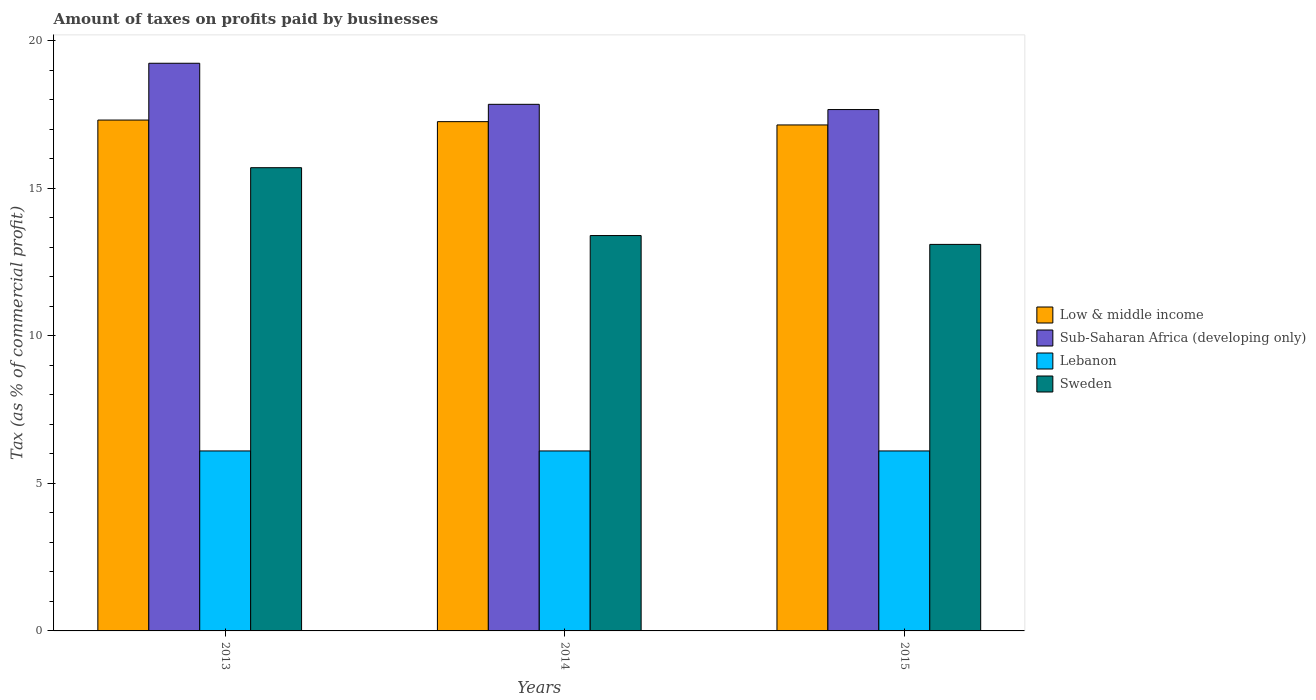How many groups of bars are there?
Provide a succinct answer. 3. Are the number of bars per tick equal to the number of legend labels?
Make the answer very short. Yes. Are the number of bars on each tick of the X-axis equal?
Make the answer very short. Yes. How many bars are there on the 2nd tick from the left?
Give a very brief answer. 4. How many bars are there on the 3rd tick from the right?
Make the answer very short. 4. What is the label of the 3rd group of bars from the left?
Provide a succinct answer. 2015. In how many cases, is the number of bars for a given year not equal to the number of legend labels?
Give a very brief answer. 0. What is the percentage of taxes paid by businesses in Sub-Saharan Africa (developing only) in 2014?
Give a very brief answer. 17.85. Across all years, what is the maximum percentage of taxes paid by businesses in Low & middle income?
Your answer should be very brief. 17.31. Across all years, what is the minimum percentage of taxes paid by businesses in Low & middle income?
Keep it short and to the point. 17.15. In which year was the percentage of taxes paid by businesses in Sub-Saharan Africa (developing only) minimum?
Make the answer very short. 2015. What is the total percentage of taxes paid by businesses in Sub-Saharan Africa (developing only) in the graph?
Keep it short and to the point. 54.76. What is the difference between the percentage of taxes paid by businesses in Sweden in 2014 and that in 2015?
Your answer should be very brief. 0.3. What is the difference between the percentage of taxes paid by businesses in Lebanon in 2014 and the percentage of taxes paid by businesses in Low & middle income in 2013?
Give a very brief answer. -11.21. What is the average percentage of taxes paid by businesses in Sub-Saharan Africa (developing only) per year?
Provide a succinct answer. 18.25. In the year 2014, what is the difference between the percentage of taxes paid by businesses in Low & middle income and percentage of taxes paid by businesses in Sub-Saharan Africa (developing only)?
Offer a very short reply. -0.59. What is the ratio of the percentage of taxes paid by businesses in Sweden in 2014 to that in 2015?
Offer a terse response. 1.02. Is the percentage of taxes paid by businesses in Lebanon in 2014 less than that in 2015?
Keep it short and to the point. No. What is the difference between the highest and the second highest percentage of taxes paid by businesses in Sweden?
Provide a succinct answer. 2.3. What is the difference between the highest and the lowest percentage of taxes paid by businesses in Lebanon?
Provide a succinct answer. 0. In how many years, is the percentage of taxes paid by businesses in Lebanon greater than the average percentage of taxes paid by businesses in Lebanon taken over all years?
Your answer should be compact. 3. Is the sum of the percentage of taxes paid by businesses in Lebanon in 2014 and 2015 greater than the maximum percentage of taxes paid by businesses in Low & middle income across all years?
Offer a very short reply. No. What does the 3rd bar from the left in 2013 represents?
Your answer should be compact. Lebanon. What does the 4th bar from the right in 2013 represents?
Ensure brevity in your answer.  Low & middle income. Is it the case that in every year, the sum of the percentage of taxes paid by businesses in Lebanon and percentage of taxes paid by businesses in Low & middle income is greater than the percentage of taxes paid by businesses in Sub-Saharan Africa (developing only)?
Give a very brief answer. Yes. How many bars are there?
Ensure brevity in your answer.  12. Are all the bars in the graph horizontal?
Your response must be concise. No. Are the values on the major ticks of Y-axis written in scientific E-notation?
Keep it short and to the point. No. Does the graph contain any zero values?
Your answer should be compact. No. What is the title of the graph?
Ensure brevity in your answer.  Amount of taxes on profits paid by businesses. What is the label or title of the Y-axis?
Provide a succinct answer. Tax (as % of commercial profit). What is the Tax (as % of commercial profit) of Low & middle income in 2013?
Your answer should be compact. 17.31. What is the Tax (as % of commercial profit) of Sub-Saharan Africa (developing only) in 2013?
Offer a very short reply. 19.24. What is the Tax (as % of commercial profit) of Sweden in 2013?
Make the answer very short. 15.7. What is the Tax (as % of commercial profit) in Low & middle income in 2014?
Ensure brevity in your answer.  17.26. What is the Tax (as % of commercial profit) in Sub-Saharan Africa (developing only) in 2014?
Your response must be concise. 17.85. What is the Tax (as % of commercial profit) in Lebanon in 2014?
Your response must be concise. 6.1. What is the Tax (as % of commercial profit) in Low & middle income in 2015?
Provide a succinct answer. 17.15. What is the Tax (as % of commercial profit) of Sub-Saharan Africa (developing only) in 2015?
Make the answer very short. 17.67. What is the Tax (as % of commercial profit) in Lebanon in 2015?
Offer a very short reply. 6.1. What is the Tax (as % of commercial profit) of Sweden in 2015?
Give a very brief answer. 13.1. Across all years, what is the maximum Tax (as % of commercial profit) of Low & middle income?
Make the answer very short. 17.31. Across all years, what is the maximum Tax (as % of commercial profit) in Sub-Saharan Africa (developing only)?
Your response must be concise. 19.24. Across all years, what is the maximum Tax (as % of commercial profit) in Lebanon?
Ensure brevity in your answer.  6.1. Across all years, what is the maximum Tax (as % of commercial profit) in Sweden?
Your answer should be compact. 15.7. Across all years, what is the minimum Tax (as % of commercial profit) in Low & middle income?
Keep it short and to the point. 17.15. Across all years, what is the minimum Tax (as % of commercial profit) of Sub-Saharan Africa (developing only)?
Offer a very short reply. 17.67. Across all years, what is the minimum Tax (as % of commercial profit) of Sweden?
Your answer should be very brief. 13.1. What is the total Tax (as % of commercial profit) in Low & middle income in the graph?
Provide a succinct answer. 51.72. What is the total Tax (as % of commercial profit) in Sub-Saharan Africa (developing only) in the graph?
Your answer should be very brief. 54.76. What is the total Tax (as % of commercial profit) in Sweden in the graph?
Keep it short and to the point. 42.2. What is the difference between the Tax (as % of commercial profit) of Low & middle income in 2013 and that in 2014?
Your answer should be compact. 0.05. What is the difference between the Tax (as % of commercial profit) of Sub-Saharan Africa (developing only) in 2013 and that in 2014?
Keep it short and to the point. 1.39. What is the difference between the Tax (as % of commercial profit) of Lebanon in 2013 and that in 2014?
Ensure brevity in your answer.  0. What is the difference between the Tax (as % of commercial profit) in Sweden in 2013 and that in 2014?
Your response must be concise. 2.3. What is the difference between the Tax (as % of commercial profit) in Low & middle income in 2013 and that in 2015?
Offer a terse response. 0.17. What is the difference between the Tax (as % of commercial profit) in Sub-Saharan Africa (developing only) in 2013 and that in 2015?
Ensure brevity in your answer.  1.57. What is the difference between the Tax (as % of commercial profit) of Lebanon in 2013 and that in 2015?
Your answer should be compact. 0. What is the difference between the Tax (as % of commercial profit) in Low & middle income in 2014 and that in 2015?
Give a very brief answer. 0.11. What is the difference between the Tax (as % of commercial profit) in Sub-Saharan Africa (developing only) in 2014 and that in 2015?
Offer a very short reply. 0.18. What is the difference between the Tax (as % of commercial profit) in Lebanon in 2014 and that in 2015?
Give a very brief answer. 0. What is the difference between the Tax (as % of commercial profit) of Low & middle income in 2013 and the Tax (as % of commercial profit) of Sub-Saharan Africa (developing only) in 2014?
Offer a very short reply. -0.53. What is the difference between the Tax (as % of commercial profit) in Low & middle income in 2013 and the Tax (as % of commercial profit) in Lebanon in 2014?
Ensure brevity in your answer.  11.21. What is the difference between the Tax (as % of commercial profit) of Low & middle income in 2013 and the Tax (as % of commercial profit) of Sweden in 2014?
Your response must be concise. 3.91. What is the difference between the Tax (as % of commercial profit) in Sub-Saharan Africa (developing only) in 2013 and the Tax (as % of commercial profit) in Lebanon in 2014?
Make the answer very short. 13.14. What is the difference between the Tax (as % of commercial profit) in Sub-Saharan Africa (developing only) in 2013 and the Tax (as % of commercial profit) in Sweden in 2014?
Give a very brief answer. 5.84. What is the difference between the Tax (as % of commercial profit) of Lebanon in 2013 and the Tax (as % of commercial profit) of Sweden in 2014?
Ensure brevity in your answer.  -7.3. What is the difference between the Tax (as % of commercial profit) in Low & middle income in 2013 and the Tax (as % of commercial profit) in Sub-Saharan Africa (developing only) in 2015?
Provide a succinct answer. -0.36. What is the difference between the Tax (as % of commercial profit) of Low & middle income in 2013 and the Tax (as % of commercial profit) of Lebanon in 2015?
Keep it short and to the point. 11.21. What is the difference between the Tax (as % of commercial profit) in Low & middle income in 2013 and the Tax (as % of commercial profit) in Sweden in 2015?
Give a very brief answer. 4.21. What is the difference between the Tax (as % of commercial profit) in Sub-Saharan Africa (developing only) in 2013 and the Tax (as % of commercial profit) in Lebanon in 2015?
Give a very brief answer. 13.14. What is the difference between the Tax (as % of commercial profit) in Sub-Saharan Africa (developing only) in 2013 and the Tax (as % of commercial profit) in Sweden in 2015?
Provide a short and direct response. 6.14. What is the difference between the Tax (as % of commercial profit) in Low & middle income in 2014 and the Tax (as % of commercial profit) in Sub-Saharan Africa (developing only) in 2015?
Ensure brevity in your answer.  -0.41. What is the difference between the Tax (as % of commercial profit) in Low & middle income in 2014 and the Tax (as % of commercial profit) in Lebanon in 2015?
Your answer should be compact. 11.16. What is the difference between the Tax (as % of commercial profit) in Low & middle income in 2014 and the Tax (as % of commercial profit) in Sweden in 2015?
Keep it short and to the point. 4.16. What is the difference between the Tax (as % of commercial profit) of Sub-Saharan Africa (developing only) in 2014 and the Tax (as % of commercial profit) of Lebanon in 2015?
Offer a terse response. 11.75. What is the difference between the Tax (as % of commercial profit) of Sub-Saharan Africa (developing only) in 2014 and the Tax (as % of commercial profit) of Sweden in 2015?
Your answer should be compact. 4.75. What is the average Tax (as % of commercial profit) in Low & middle income per year?
Offer a very short reply. 17.24. What is the average Tax (as % of commercial profit) of Sub-Saharan Africa (developing only) per year?
Offer a very short reply. 18.25. What is the average Tax (as % of commercial profit) in Sweden per year?
Keep it short and to the point. 14.07. In the year 2013, what is the difference between the Tax (as % of commercial profit) in Low & middle income and Tax (as % of commercial profit) in Sub-Saharan Africa (developing only)?
Your response must be concise. -1.93. In the year 2013, what is the difference between the Tax (as % of commercial profit) in Low & middle income and Tax (as % of commercial profit) in Lebanon?
Your answer should be compact. 11.21. In the year 2013, what is the difference between the Tax (as % of commercial profit) in Low & middle income and Tax (as % of commercial profit) in Sweden?
Your response must be concise. 1.61. In the year 2013, what is the difference between the Tax (as % of commercial profit) of Sub-Saharan Africa (developing only) and Tax (as % of commercial profit) of Lebanon?
Your answer should be very brief. 13.14. In the year 2013, what is the difference between the Tax (as % of commercial profit) in Sub-Saharan Africa (developing only) and Tax (as % of commercial profit) in Sweden?
Provide a succinct answer. 3.54. In the year 2014, what is the difference between the Tax (as % of commercial profit) of Low & middle income and Tax (as % of commercial profit) of Sub-Saharan Africa (developing only)?
Give a very brief answer. -0.59. In the year 2014, what is the difference between the Tax (as % of commercial profit) in Low & middle income and Tax (as % of commercial profit) in Lebanon?
Ensure brevity in your answer.  11.16. In the year 2014, what is the difference between the Tax (as % of commercial profit) of Low & middle income and Tax (as % of commercial profit) of Sweden?
Provide a short and direct response. 3.86. In the year 2014, what is the difference between the Tax (as % of commercial profit) in Sub-Saharan Africa (developing only) and Tax (as % of commercial profit) in Lebanon?
Offer a very short reply. 11.75. In the year 2014, what is the difference between the Tax (as % of commercial profit) of Sub-Saharan Africa (developing only) and Tax (as % of commercial profit) of Sweden?
Provide a short and direct response. 4.45. In the year 2014, what is the difference between the Tax (as % of commercial profit) in Lebanon and Tax (as % of commercial profit) in Sweden?
Ensure brevity in your answer.  -7.3. In the year 2015, what is the difference between the Tax (as % of commercial profit) of Low & middle income and Tax (as % of commercial profit) of Sub-Saharan Africa (developing only)?
Make the answer very short. -0.52. In the year 2015, what is the difference between the Tax (as % of commercial profit) in Low & middle income and Tax (as % of commercial profit) in Lebanon?
Provide a succinct answer. 11.05. In the year 2015, what is the difference between the Tax (as % of commercial profit) in Low & middle income and Tax (as % of commercial profit) in Sweden?
Keep it short and to the point. 4.05. In the year 2015, what is the difference between the Tax (as % of commercial profit) of Sub-Saharan Africa (developing only) and Tax (as % of commercial profit) of Lebanon?
Your answer should be very brief. 11.57. In the year 2015, what is the difference between the Tax (as % of commercial profit) in Sub-Saharan Africa (developing only) and Tax (as % of commercial profit) in Sweden?
Your response must be concise. 4.57. In the year 2015, what is the difference between the Tax (as % of commercial profit) in Lebanon and Tax (as % of commercial profit) in Sweden?
Your response must be concise. -7. What is the ratio of the Tax (as % of commercial profit) of Low & middle income in 2013 to that in 2014?
Give a very brief answer. 1. What is the ratio of the Tax (as % of commercial profit) of Sub-Saharan Africa (developing only) in 2013 to that in 2014?
Provide a short and direct response. 1.08. What is the ratio of the Tax (as % of commercial profit) in Sweden in 2013 to that in 2014?
Ensure brevity in your answer.  1.17. What is the ratio of the Tax (as % of commercial profit) of Low & middle income in 2013 to that in 2015?
Your response must be concise. 1.01. What is the ratio of the Tax (as % of commercial profit) in Sub-Saharan Africa (developing only) in 2013 to that in 2015?
Provide a succinct answer. 1.09. What is the ratio of the Tax (as % of commercial profit) in Lebanon in 2013 to that in 2015?
Provide a succinct answer. 1. What is the ratio of the Tax (as % of commercial profit) of Sweden in 2013 to that in 2015?
Offer a terse response. 1.2. What is the ratio of the Tax (as % of commercial profit) of Lebanon in 2014 to that in 2015?
Make the answer very short. 1. What is the ratio of the Tax (as % of commercial profit) in Sweden in 2014 to that in 2015?
Ensure brevity in your answer.  1.02. What is the difference between the highest and the second highest Tax (as % of commercial profit) in Low & middle income?
Keep it short and to the point. 0.05. What is the difference between the highest and the second highest Tax (as % of commercial profit) in Sub-Saharan Africa (developing only)?
Provide a succinct answer. 1.39. What is the difference between the highest and the second highest Tax (as % of commercial profit) in Lebanon?
Your answer should be compact. 0. What is the difference between the highest and the lowest Tax (as % of commercial profit) in Low & middle income?
Your answer should be very brief. 0.17. What is the difference between the highest and the lowest Tax (as % of commercial profit) in Sub-Saharan Africa (developing only)?
Your answer should be compact. 1.57. 